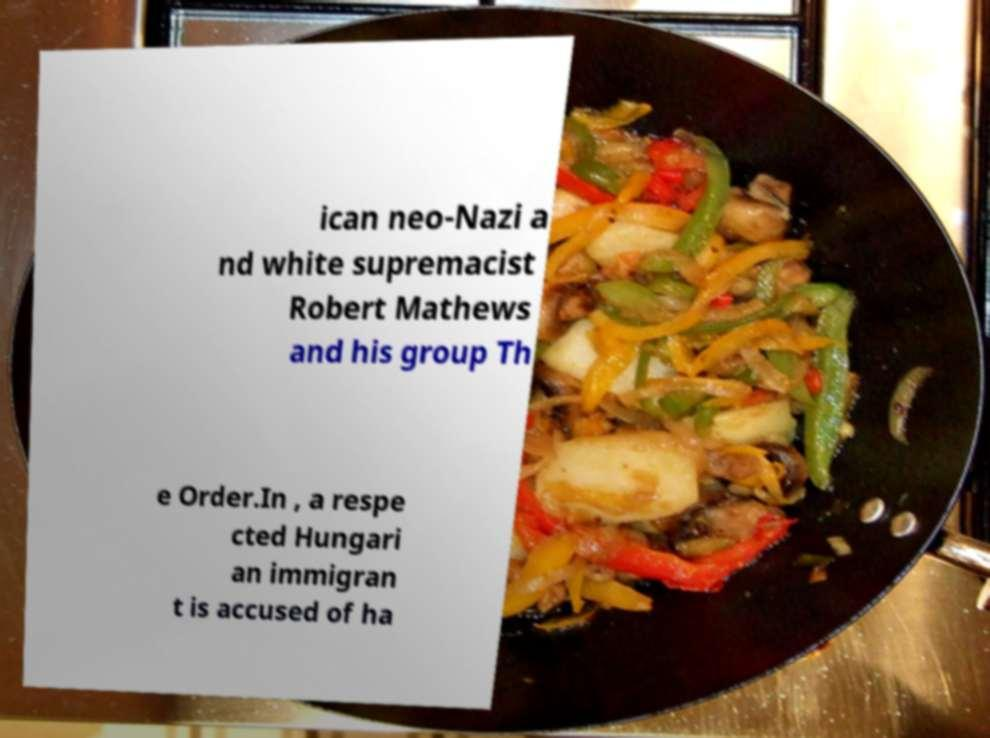Can you accurately transcribe the text from the provided image for me? ican neo-Nazi a nd white supremacist Robert Mathews and his group Th e Order.In , a respe cted Hungari an immigran t is accused of ha 